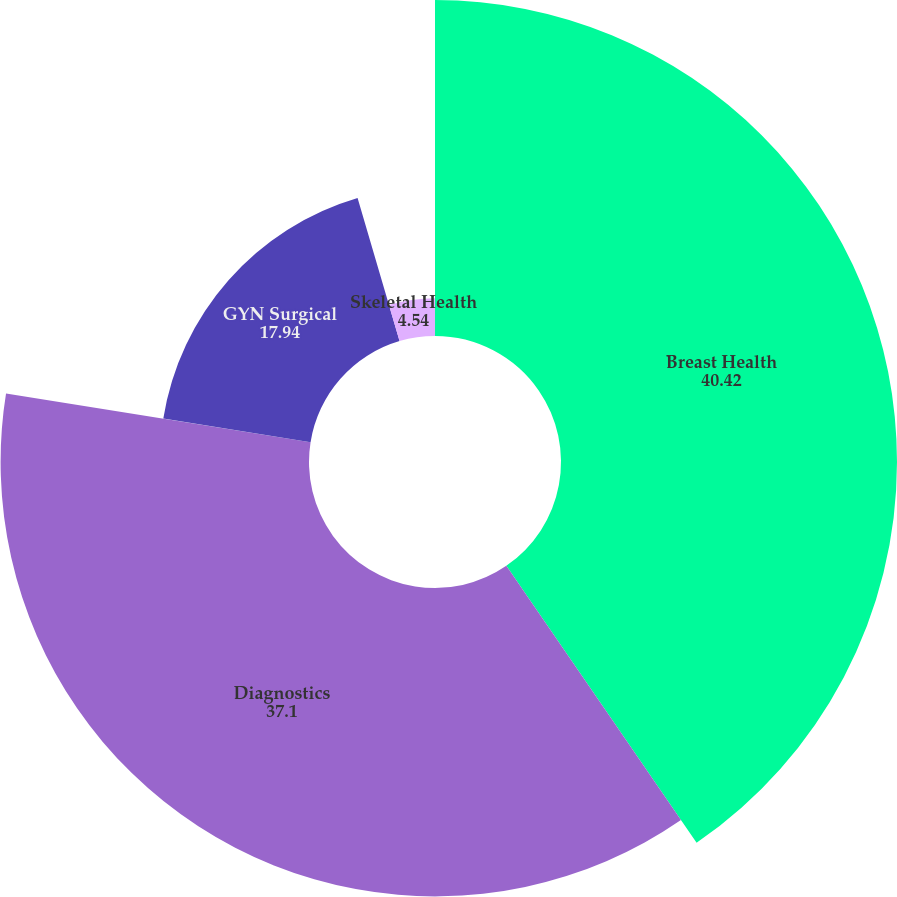Convert chart to OTSL. <chart><loc_0><loc_0><loc_500><loc_500><pie_chart><fcel>Breast Health<fcel>Diagnostics<fcel>GYN Surgical<fcel>Skeletal Health<nl><fcel>40.42%<fcel>37.1%<fcel>17.94%<fcel>4.54%<nl></chart> 